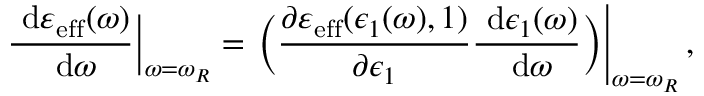Convert formula to latex. <formula><loc_0><loc_0><loc_500><loc_500>\frac { \ d \varepsilon _ { e f f } ( \omega ) } { \ d \omega } \Big | _ { \omega = \omega _ { R } } = \Big ( \frac { \partial \varepsilon _ { e f f } ( \epsilon _ { 1 } ( \omega ) , 1 ) } { \partial \epsilon _ { 1 } } \frac { \ d \epsilon _ { 1 } ( \omega ) } { \ d \omega } \Big ) \right | _ { \omega = \omega _ { R } } ,</formula> 